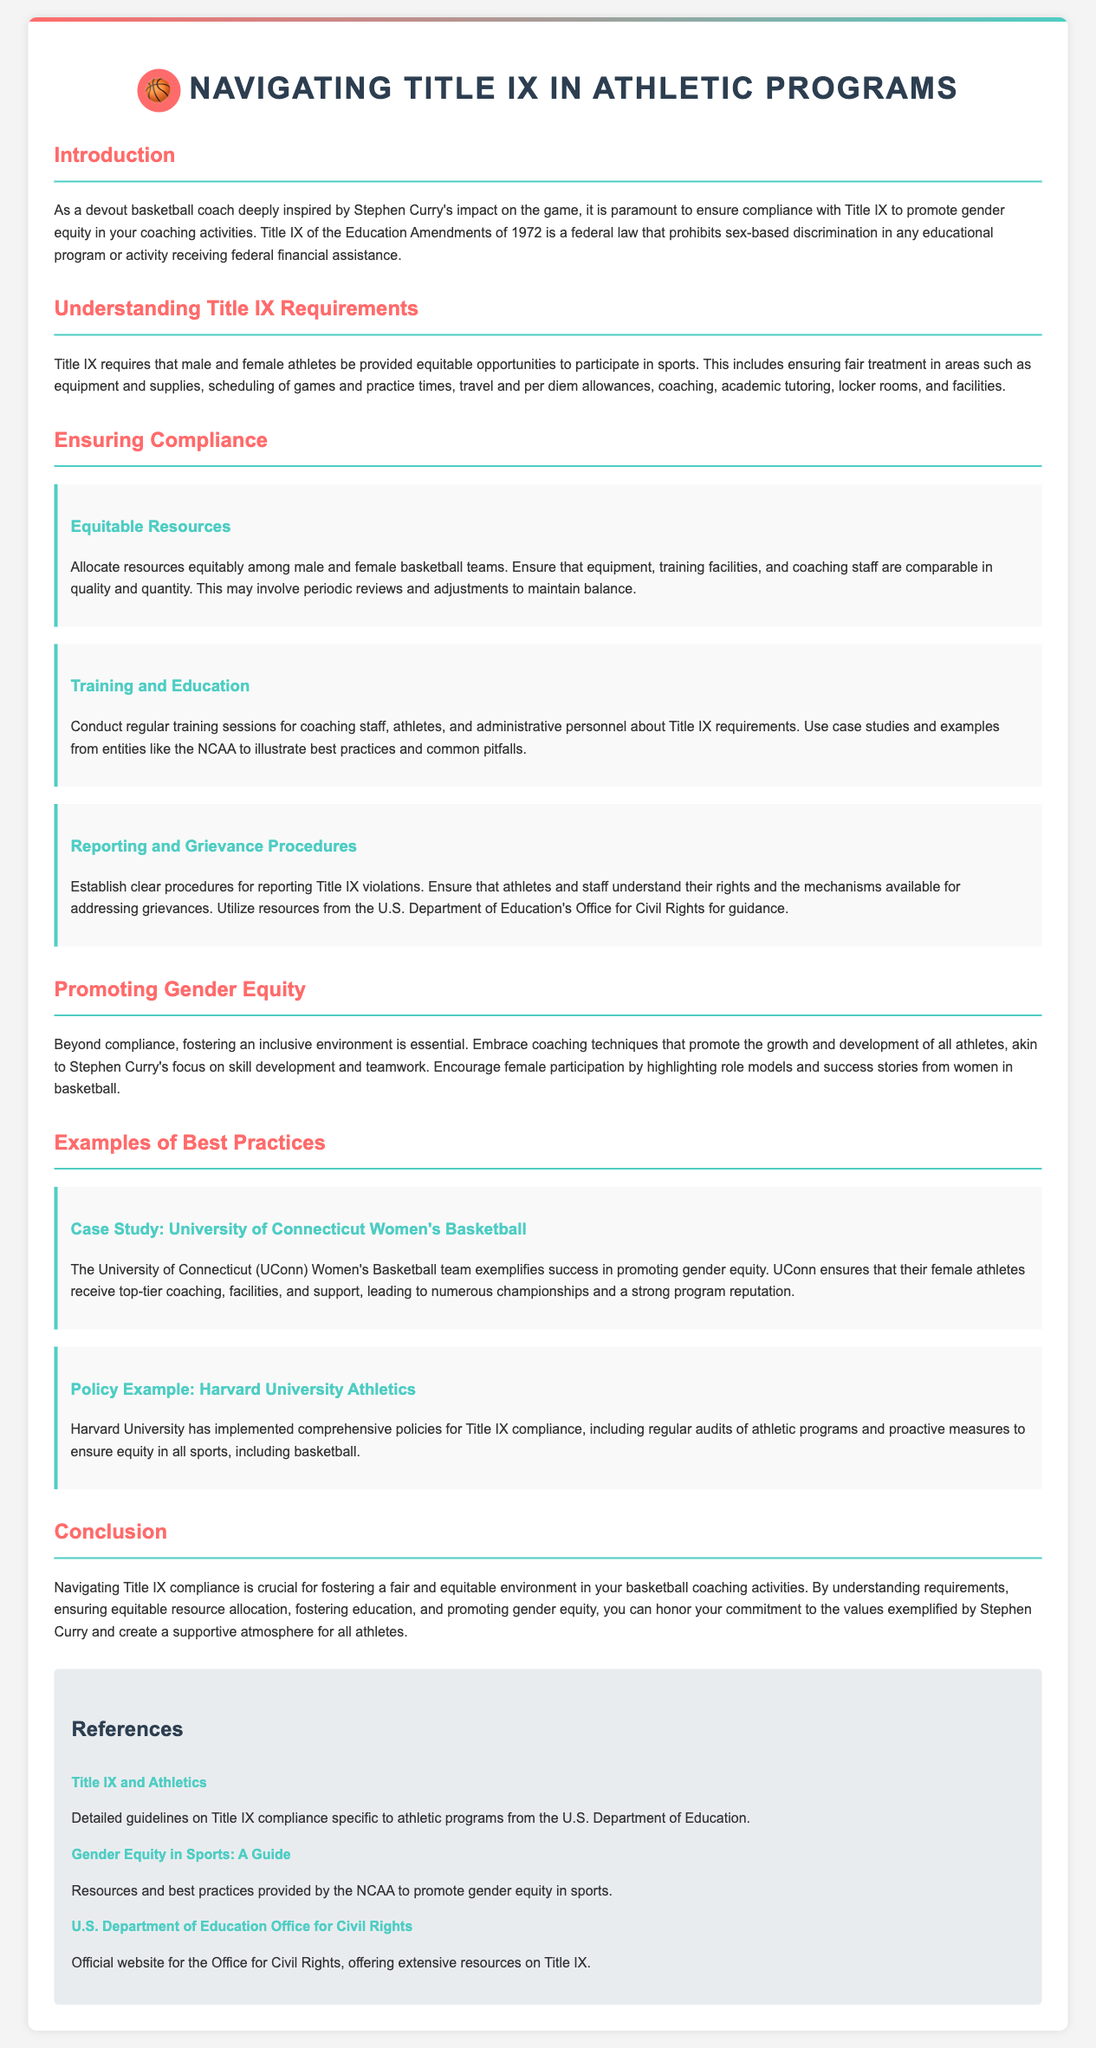What is Title IX? Title IX is a federal law that prohibits sex-based discrimination in any educational program or activity receiving federal financial assistance.
Answer: A federal law What is the main goal of Title IX in sports? Title IX requires that male and female athletes be provided equitable opportunities to participate in sports.
Answer: Gender equity Which university is mentioned as an example of success in promoting gender equity? The University of Connecticut Women's Basketball team exemplifies success in promoting gender equity.
Answer: University of Connecticut What should be ensured for equitable resources? Ensure that equipment, training facilities, and coaching staff are comparable in quality and quantity.
Answer: Comparable quality and quantity What type of procedures should be established for Title IX violations? Establish clear procedures for reporting Title IX violations.
Answer: Reporting procedures Which document section highlights training sessions for staff? The section called "Training and Education" emphasizes conducting regular training sessions for coaching staff, athletes, and administrative personnel.
Answer: Training and Education What is one of the approaches to promote female participation in basketball? Encourage female participation by highlighting role models and success stories from women in basketball.
Answer: Highlighting role models What is the conclusion of the legal brief focused on? The conclusion emphasizes the importance of navigating Title IX compliance for fostering a fair and equitable environment in basketball coaching activities.
Answer: Title IX compliance 